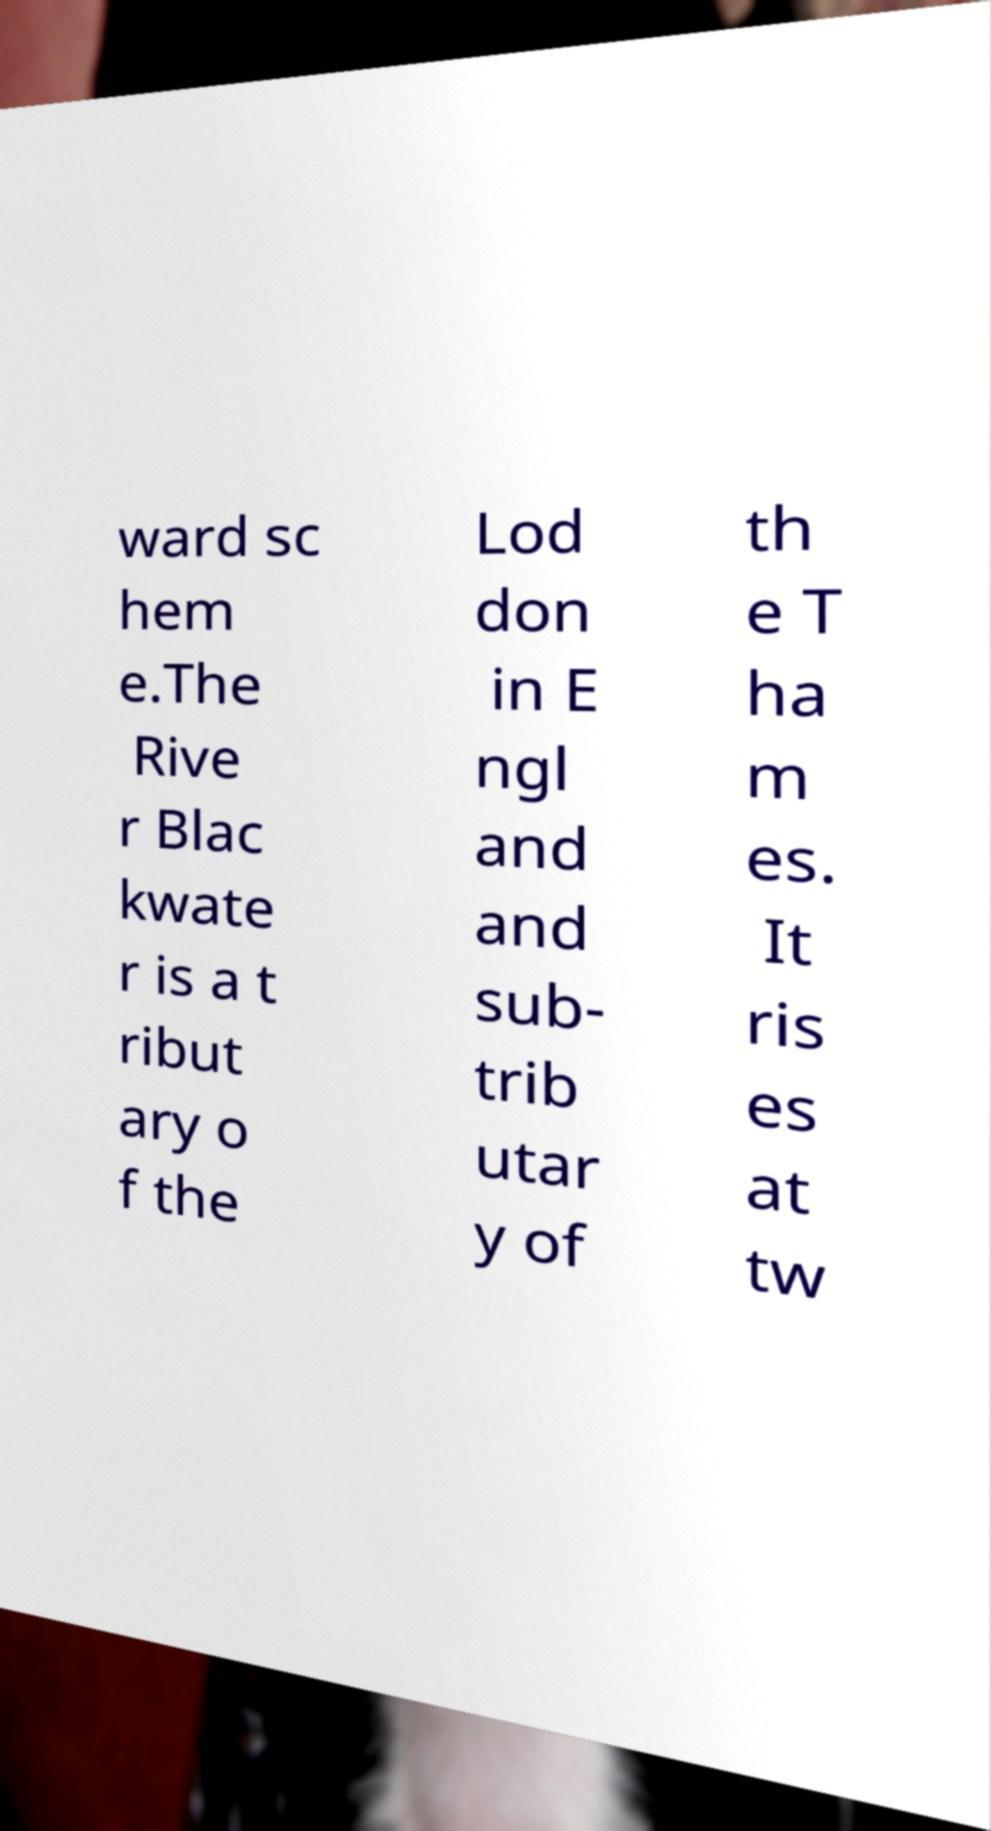Could you assist in decoding the text presented in this image and type it out clearly? ward sc hem e.The Rive r Blac kwate r is a t ribut ary o f the Lod don in E ngl and and sub- trib utar y of th e T ha m es. It ris es at tw 